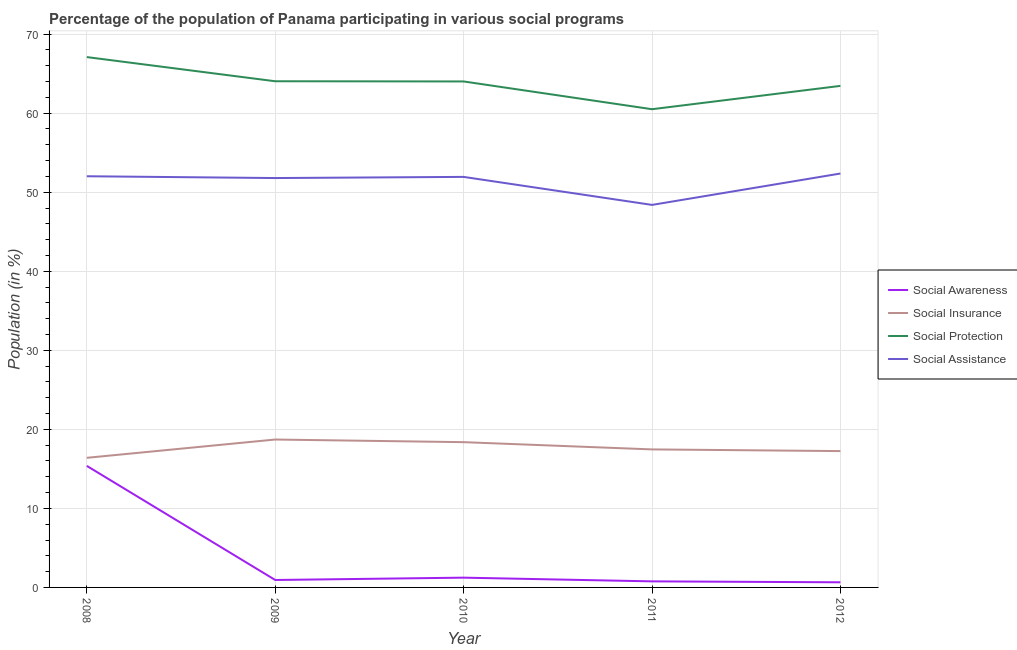How many different coloured lines are there?
Provide a succinct answer. 4. Does the line corresponding to participation of population in social assistance programs intersect with the line corresponding to participation of population in social insurance programs?
Ensure brevity in your answer.  No. What is the participation of population in social awareness programs in 2009?
Ensure brevity in your answer.  0.94. Across all years, what is the maximum participation of population in social insurance programs?
Give a very brief answer. 18.71. Across all years, what is the minimum participation of population in social assistance programs?
Offer a terse response. 48.4. In which year was the participation of population in social protection programs minimum?
Your response must be concise. 2011. What is the total participation of population in social assistance programs in the graph?
Keep it short and to the point. 256.52. What is the difference between the participation of population in social insurance programs in 2008 and that in 2009?
Provide a short and direct response. -2.31. What is the difference between the participation of population in social protection programs in 2009 and the participation of population in social insurance programs in 2010?
Ensure brevity in your answer.  45.66. What is the average participation of population in social protection programs per year?
Keep it short and to the point. 63.82. In the year 2012, what is the difference between the participation of population in social assistance programs and participation of population in social awareness programs?
Your response must be concise. 51.72. What is the ratio of the participation of population in social awareness programs in 2008 to that in 2009?
Give a very brief answer. 16.32. Is the participation of population in social assistance programs in 2008 less than that in 2012?
Make the answer very short. Yes. Is the difference between the participation of population in social awareness programs in 2009 and 2012 greater than the difference between the participation of population in social insurance programs in 2009 and 2012?
Your answer should be very brief. No. What is the difference between the highest and the second highest participation of population in social assistance programs?
Give a very brief answer. 0.35. What is the difference between the highest and the lowest participation of population in social protection programs?
Provide a short and direct response. 6.59. In how many years, is the participation of population in social protection programs greater than the average participation of population in social protection programs taken over all years?
Ensure brevity in your answer.  3. Is the sum of the participation of population in social insurance programs in 2008 and 2012 greater than the maximum participation of population in social awareness programs across all years?
Ensure brevity in your answer.  Yes. Is it the case that in every year, the sum of the participation of population in social protection programs and participation of population in social awareness programs is greater than the sum of participation of population in social insurance programs and participation of population in social assistance programs?
Your answer should be compact. Yes. Does the participation of population in social awareness programs monotonically increase over the years?
Keep it short and to the point. No. Is the participation of population in social insurance programs strictly less than the participation of population in social protection programs over the years?
Give a very brief answer. Yes. How many lines are there?
Your answer should be very brief. 4. Where does the legend appear in the graph?
Your response must be concise. Center right. What is the title of the graph?
Provide a short and direct response. Percentage of the population of Panama participating in various social programs . Does "Debt policy" appear as one of the legend labels in the graph?
Provide a short and direct response. No. What is the label or title of the X-axis?
Offer a very short reply. Year. What is the Population (in %) in Social Awareness in 2008?
Provide a short and direct response. 15.38. What is the Population (in %) of Social Insurance in 2008?
Give a very brief answer. 16.4. What is the Population (in %) in Social Protection in 2008?
Your response must be concise. 67.1. What is the Population (in %) of Social Assistance in 2008?
Make the answer very short. 52.02. What is the Population (in %) of Social Awareness in 2009?
Offer a terse response. 0.94. What is the Population (in %) in Social Insurance in 2009?
Ensure brevity in your answer.  18.71. What is the Population (in %) in Social Protection in 2009?
Offer a very short reply. 64.04. What is the Population (in %) in Social Assistance in 2009?
Provide a succinct answer. 51.79. What is the Population (in %) of Social Awareness in 2010?
Provide a succinct answer. 1.24. What is the Population (in %) of Social Insurance in 2010?
Provide a succinct answer. 18.38. What is the Population (in %) of Social Protection in 2010?
Offer a terse response. 64.02. What is the Population (in %) of Social Assistance in 2010?
Make the answer very short. 51.94. What is the Population (in %) in Social Awareness in 2011?
Your answer should be compact. 0.77. What is the Population (in %) in Social Insurance in 2011?
Keep it short and to the point. 17.46. What is the Population (in %) in Social Protection in 2011?
Offer a very short reply. 60.5. What is the Population (in %) in Social Assistance in 2011?
Offer a terse response. 48.4. What is the Population (in %) in Social Awareness in 2012?
Your answer should be compact. 0.65. What is the Population (in %) in Social Insurance in 2012?
Offer a terse response. 17.25. What is the Population (in %) in Social Protection in 2012?
Make the answer very short. 63.45. What is the Population (in %) of Social Assistance in 2012?
Give a very brief answer. 52.37. Across all years, what is the maximum Population (in %) of Social Awareness?
Make the answer very short. 15.38. Across all years, what is the maximum Population (in %) in Social Insurance?
Your answer should be compact. 18.71. Across all years, what is the maximum Population (in %) of Social Protection?
Your answer should be compact. 67.1. Across all years, what is the maximum Population (in %) in Social Assistance?
Give a very brief answer. 52.37. Across all years, what is the minimum Population (in %) of Social Awareness?
Make the answer very short. 0.65. Across all years, what is the minimum Population (in %) in Social Insurance?
Give a very brief answer. 16.4. Across all years, what is the minimum Population (in %) of Social Protection?
Your answer should be very brief. 60.5. Across all years, what is the minimum Population (in %) of Social Assistance?
Give a very brief answer. 48.4. What is the total Population (in %) of Social Awareness in the graph?
Your answer should be very brief. 18.97. What is the total Population (in %) of Social Insurance in the graph?
Keep it short and to the point. 88.2. What is the total Population (in %) in Social Protection in the graph?
Offer a terse response. 319.11. What is the total Population (in %) in Social Assistance in the graph?
Keep it short and to the point. 256.52. What is the difference between the Population (in %) in Social Awareness in 2008 and that in 2009?
Ensure brevity in your answer.  14.43. What is the difference between the Population (in %) of Social Insurance in 2008 and that in 2009?
Your answer should be very brief. -2.31. What is the difference between the Population (in %) in Social Protection in 2008 and that in 2009?
Your answer should be very brief. 3.06. What is the difference between the Population (in %) of Social Assistance in 2008 and that in 2009?
Your response must be concise. 0.23. What is the difference between the Population (in %) of Social Awareness in 2008 and that in 2010?
Provide a short and direct response. 14.14. What is the difference between the Population (in %) in Social Insurance in 2008 and that in 2010?
Provide a short and direct response. -1.98. What is the difference between the Population (in %) of Social Protection in 2008 and that in 2010?
Offer a very short reply. 3.08. What is the difference between the Population (in %) in Social Assistance in 2008 and that in 2010?
Make the answer very short. 0.08. What is the difference between the Population (in %) in Social Awareness in 2008 and that in 2011?
Give a very brief answer. 14.61. What is the difference between the Population (in %) in Social Insurance in 2008 and that in 2011?
Keep it short and to the point. -1.06. What is the difference between the Population (in %) of Social Protection in 2008 and that in 2011?
Ensure brevity in your answer.  6.59. What is the difference between the Population (in %) in Social Assistance in 2008 and that in 2011?
Offer a very short reply. 3.62. What is the difference between the Population (in %) of Social Awareness in 2008 and that in 2012?
Ensure brevity in your answer.  14.73. What is the difference between the Population (in %) in Social Insurance in 2008 and that in 2012?
Keep it short and to the point. -0.85. What is the difference between the Population (in %) in Social Protection in 2008 and that in 2012?
Keep it short and to the point. 3.64. What is the difference between the Population (in %) of Social Assistance in 2008 and that in 2012?
Offer a very short reply. -0.35. What is the difference between the Population (in %) in Social Awareness in 2009 and that in 2010?
Make the answer very short. -0.29. What is the difference between the Population (in %) in Social Insurance in 2009 and that in 2010?
Your response must be concise. 0.33. What is the difference between the Population (in %) in Social Protection in 2009 and that in 2010?
Give a very brief answer. 0.02. What is the difference between the Population (in %) in Social Assistance in 2009 and that in 2010?
Provide a short and direct response. -0.15. What is the difference between the Population (in %) in Social Awareness in 2009 and that in 2011?
Offer a very short reply. 0.17. What is the difference between the Population (in %) in Social Insurance in 2009 and that in 2011?
Provide a succinct answer. 1.25. What is the difference between the Population (in %) of Social Protection in 2009 and that in 2011?
Offer a very short reply. 3.54. What is the difference between the Population (in %) of Social Assistance in 2009 and that in 2011?
Give a very brief answer. 3.4. What is the difference between the Population (in %) of Social Awareness in 2009 and that in 2012?
Your answer should be compact. 0.29. What is the difference between the Population (in %) of Social Insurance in 2009 and that in 2012?
Your answer should be very brief. 1.46. What is the difference between the Population (in %) of Social Protection in 2009 and that in 2012?
Your answer should be compact. 0.59. What is the difference between the Population (in %) of Social Assistance in 2009 and that in 2012?
Ensure brevity in your answer.  -0.57. What is the difference between the Population (in %) of Social Awareness in 2010 and that in 2011?
Give a very brief answer. 0.47. What is the difference between the Population (in %) in Social Insurance in 2010 and that in 2011?
Make the answer very short. 0.92. What is the difference between the Population (in %) of Social Protection in 2010 and that in 2011?
Give a very brief answer. 3.51. What is the difference between the Population (in %) of Social Assistance in 2010 and that in 2011?
Ensure brevity in your answer.  3.54. What is the difference between the Population (in %) of Social Awareness in 2010 and that in 2012?
Give a very brief answer. 0.59. What is the difference between the Population (in %) of Social Insurance in 2010 and that in 2012?
Keep it short and to the point. 1.13. What is the difference between the Population (in %) in Social Protection in 2010 and that in 2012?
Your answer should be very brief. 0.56. What is the difference between the Population (in %) in Social Assistance in 2010 and that in 2012?
Keep it short and to the point. -0.43. What is the difference between the Population (in %) in Social Awareness in 2011 and that in 2012?
Provide a short and direct response. 0.12. What is the difference between the Population (in %) of Social Insurance in 2011 and that in 2012?
Keep it short and to the point. 0.21. What is the difference between the Population (in %) of Social Protection in 2011 and that in 2012?
Provide a short and direct response. -2.95. What is the difference between the Population (in %) of Social Assistance in 2011 and that in 2012?
Make the answer very short. -3.97. What is the difference between the Population (in %) of Social Awareness in 2008 and the Population (in %) of Social Insurance in 2009?
Keep it short and to the point. -3.34. What is the difference between the Population (in %) of Social Awareness in 2008 and the Population (in %) of Social Protection in 2009?
Your answer should be very brief. -48.66. What is the difference between the Population (in %) of Social Awareness in 2008 and the Population (in %) of Social Assistance in 2009?
Make the answer very short. -36.42. What is the difference between the Population (in %) in Social Insurance in 2008 and the Population (in %) in Social Protection in 2009?
Your answer should be compact. -47.64. What is the difference between the Population (in %) in Social Insurance in 2008 and the Population (in %) in Social Assistance in 2009?
Offer a very short reply. -35.39. What is the difference between the Population (in %) in Social Protection in 2008 and the Population (in %) in Social Assistance in 2009?
Make the answer very short. 15.3. What is the difference between the Population (in %) in Social Awareness in 2008 and the Population (in %) in Social Insurance in 2010?
Give a very brief answer. -3. What is the difference between the Population (in %) of Social Awareness in 2008 and the Population (in %) of Social Protection in 2010?
Your answer should be very brief. -48.64. What is the difference between the Population (in %) of Social Awareness in 2008 and the Population (in %) of Social Assistance in 2010?
Give a very brief answer. -36.56. What is the difference between the Population (in %) in Social Insurance in 2008 and the Population (in %) in Social Protection in 2010?
Your response must be concise. -47.62. What is the difference between the Population (in %) of Social Insurance in 2008 and the Population (in %) of Social Assistance in 2010?
Ensure brevity in your answer.  -35.54. What is the difference between the Population (in %) in Social Protection in 2008 and the Population (in %) in Social Assistance in 2010?
Keep it short and to the point. 15.16. What is the difference between the Population (in %) in Social Awareness in 2008 and the Population (in %) in Social Insurance in 2011?
Ensure brevity in your answer.  -2.09. What is the difference between the Population (in %) of Social Awareness in 2008 and the Population (in %) of Social Protection in 2011?
Offer a terse response. -45.13. What is the difference between the Population (in %) in Social Awareness in 2008 and the Population (in %) in Social Assistance in 2011?
Make the answer very short. -33.02. What is the difference between the Population (in %) in Social Insurance in 2008 and the Population (in %) in Social Protection in 2011?
Ensure brevity in your answer.  -44.1. What is the difference between the Population (in %) of Social Insurance in 2008 and the Population (in %) of Social Assistance in 2011?
Your answer should be compact. -32. What is the difference between the Population (in %) of Social Protection in 2008 and the Population (in %) of Social Assistance in 2011?
Keep it short and to the point. 18.7. What is the difference between the Population (in %) of Social Awareness in 2008 and the Population (in %) of Social Insurance in 2012?
Ensure brevity in your answer.  -1.87. What is the difference between the Population (in %) of Social Awareness in 2008 and the Population (in %) of Social Protection in 2012?
Make the answer very short. -48.08. What is the difference between the Population (in %) in Social Awareness in 2008 and the Population (in %) in Social Assistance in 2012?
Your answer should be very brief. -36.99. What is the difference between the Population (in %) in Social Insurance in 2008 and the Population (in %) in Social Protection in 2012?
Offer a terse response. -47.05. What is the difference between the Population (in %) in Social Insurance in 2008 and the Population (in %) in Social Assistance in 2012?
Provide a succinct answer. -35.97. What is the difference between the Population (in %) in Social Protection in 2008 and the Population (in %) in Social Assistance in 2012?
Provide a succinct answer. 14.73. What is the difference between the Population (in %) of Social Awareness in 2009 and the Population (in %) of Social Insurance in 2010?
Your answer should be compact. -17.44. What is the difference between the Population (in %) in Social Awareness in 2009 and the Population (in %) in Social Protection in 2010?
Offer a terse response. -63.07. What is the difference between the Population (in %) in Social Awareness in 2009 and the Population (in %) in Social Assistance in 2010?
Provide a succinct answer. -51. What is the difference between the Population (in %) in Social Insurance in 2009 and the Population (in %) in Social Protection in 2010?
Your response must be concise. -45.3. What is the difference between the Population (in %) of Social Insurance in 2009 and the Population (in %) of Social Assistance in 2010?
Make the answer very short. -33.23. What is the difference between the Population (in %) in Social Protection in 2009 and the Population (in %) in Social Assistance in 2010?
Offer a terse response. 12.1. What is the difference between the Population (in %) of Social Awareness in 2009 and the Population (in %) of Social Insurance in 2011?
Offer a very short reply. -16.52. What is the difference between the Population (in %) of Social Awareness in 2009 and the Population (in %) of Social Protection in 2011?
Provide a succinct answer. -59.56. What is the difference between the Population (in %) of Social Awareness in 2009 and the Population (in %) of Social Assistance in 2011?
Your response must be concise. -47.45. What is the difference between the Population (in %) of Social Insurance in 2009 and the Population (in %) of Social Protection in 2011?
Offer a very short reply. -41.79. What is the difference between the Population (in %) in Social Insurance in 2009 and the Population (in %) in Social Assistance in 2011?
Provide a succinct answer. -29.68. What is the difference between the Population (in %) in Social Protection in 2009 and the Population (in %) in Social Assistance in 2011?
Ensure brevity in your answer.  15.64. What is the difference between the Population (in %) in Social Awareness in 2009 and the Population (in %) in Social Insurance in 2012?
Ensure brevity in your answer.  -16.31. What is the difference between the Population (in %) in Social Awareness in 2009 and the Population (in %) in Social Protection in 2012?
Your response must be concise. -62.51. What is the difference between the Population (in %) in Social Awareness in 2009 and the Population (in %) in Social Assistance in 2012?
Provide a short and direct response. -51.42. What is the difference between the Population (in %) in Social Insurance in 2009 and the Population (in %) in Social Protection in 2012?
Your response must be concise. -44.74. What is the difference between the Population (in %) of Social Insurance in 2009 and the Population (in %) of Social Assistance in 2012?
Your answer should be very brief. -33.65. What is the difference between the Population (in %) in Social Protection in 2009 and the Population (in %) in Social Assistance in 2012?
Provide a short and direct response. 11.67. What is the difference between the Population (in %) in Social Awareness in 2010 and the Population (in %) in Social Insurance in 2011?
Give a very brief answer. -16.23. What is the difference between the Population (in %) of Social Awareness in 2010 and the Population (in %) of Social Protection in 2011?
Offer a terse response. -59.27. What is the difference between the Population (in %) in Social Awareness in 2010 and the Population (in %) in Social Assistance in 2011?
Make the answer very short. -47.16. What is the difference between the Population (in %) of Social Insurance in 2010 and the Population (in %) of Social Protection in 2011?
Provide a succinct answer. -42.12. What is the difference between the Population (in %) of Social Insurance in 2010 and the Population (in %) of Social Assistance in 2011?
Ensure brevity in your answer.  -30.02. What is the difference between the Population (in %) in Social Protection in 2010 and the Population (in %) in Social Assistance in 2011?
Your answer should be compact. 15.62. What is the difference between the Population (in %) in Social Awareness in 2010 and the Population (in %) in Social Insurance in 2012?
Offer a very short reply. -16.01. What is the difference between the Population (in %) in Social Awareness in 2010 and the Population (in %) in Social Protection in 2012?
Ensure brevity in your answer.  -62.22. What is the difference between the Population (in %) of Social Awareness in 2010 and the Population (in %) of Social Assistance in 2012?
Your answer should be very brief. -51.13. What is the difference between the Population (in %) in Social Insurance in 2010 and the Population (in %) in Social Protection in 2012?
Give a very brief answer. -45.07. What is the difference between the Population (in %) in Social Insurance in 2010 and the Population (in %) in Social Assistance in 2012?
Provide a short and direct response. -33.99. What is the difference between the Population (in %) of Social Protection in 2010 and the Population (in %) of Social Assistance in 2012?
Ensure brevity in your answer.  11.65. What is the difference between the Population (in %) of Social Awareness in 2011 and the Population (in %) of Social Insurance in 2012?
Ensure brevity in your answer.  -16.48. What is the difference between the Population (in %) in Social Awareness in 2011 and the Population (in %) in Social Protection in 2012?
Provide a short and direct response. -62.69. What is the difference between the Population (in %) of Social Awareness in 2011 and the Population (in %) of Social Assistance in 2012?
Your response must be concise. -51.6. What is the difference between the Population (in %) of Social Insurance in 2011 and the Population (in %) of Social Protection in 2012?
Your answer should be compact. -45.99. What is the difference between the Population (in %) of Social Insurance in 2011 and the Population (in %) of Social Assistance in 2012?
Offer a very short reply. -34.9. What is the difference between the Population (in %) of Social Protection in 2011 and the Population (in %) of Social Assistance in 2012?
Make the answer very short. 8.14. What is the average Population (in %) of Social Awareness per year?
Provide a succinct answer. 3.79. What is the average Population (in %) in Social Insurance per year?
Your answer should be compact. 17.64. What is the average Population (in %) in Social Protection per year?
Your answer should be very brief. 63.82. What is the average Population (in %) of Social Assistance per year?
Provide a short and direct response. 51.3. In the year 2008, what is the difference between the Population (in %) in Social Awareness and Population (in %) in Social Insurance?
Ensure brevity in your answer.  -1.02. In the year 2008, what is the difference between the Population (in %) of Social Awareness and Population (in %) of Social Protection?
Offer a very short reply. -51.72. In the year 2008, what is the difference between the Population (in %) in Social Awareness and Population (in %) in Social Assistance?
Provide a succinct answer. -36.65. In the year 2008, what is the difference between the Population (in %) in Social Insurance and Population (in %) in Social Protection?
Keep it short and to the point. -50.7. In the year 2008, what is the difference between the Population (in %) in Social Insurance and Population (in %) in Social Assistance?
Offer a very short reply. -35.62. In the year 2008, what is the difference between the Population (in %) of Social Protection and Population (in %) of Social Assistance?
Your response must be concise. 15.08. In the year 2009, what is the difference between the Population (in %) of Social Awareness and Population (in %) of Social Insurance?
Offer a very short reply. -17.77. In the year 2009, what is the difference between the Population (in %) in Social Awareness and Population (in %) in Social Protection?
Your answer should be compact. -63.1. In the year 2009, what is the difference between the Population (in %) in Social Awareness and Population (in %) in Social Assistance?
Your answer should be compact. -50.85. In the year 2009, what is the difference between the Population (in %) of Social Insurance and Population (in %) of Social Protection?
Give a very brief answer. -45.33. In the year 2009, what is the difference between the Population (in %) in Social Insurance and Population (in %) in Social Assistance?
Your answer should be compact. -33.08. In the year 2009, what is the difference between the Population (in %) of Social Protection and Population (in %) of Social Assistance?
Ensure brevity in your answer.  12.25. In the year 2010, what is the difference between the Population (in %) of Social Awareness and Population (in %) of Social Insurance?
Ensure brevity in your answer.  -17.14. In the year 2010, what is the difference between the Population (in %) of Social Awareness and Population (in %) of Social Protection?
Provide a short and direct response. -62.78. In the year 2010, what is the difference between the Population (in %) in Social Awareness and Population (in %) in Social Assistance?
Your response must be concise. -50.7. In the year 2010, what is the difference between the Population (in %) of Social Insurance and Population (in %) of Social Protection?
Make the answer very short. -45.64. In the year 2010, what is the difference between the Population (in %) of Social Insurance and Population (in %) of Social Assistance?
Provide a succinct answer. -33.56. In the year 2010, what is the difference between the Population (in %) of Social Protection and Population (in %) of Social Assistance?
Your answer should be very brief. 12.08. In the year 2011, what is the difference between the Population (in %) of Social Awareness and Population (in %) of Social Insurance?
Ensure brevity in your answer.  -16.7. In the year 2011, what is the difference between the Population (in %) in Social Awareness and Population (in %) in Social Protection?
Provide a short and direct response. -59.74. In the year 2011, what is the difference between the Population (in %) in Social Awareness and Population (in %) in Social Assistance?
Give a very brief answer. -47.63. In the year 2011, what is the difference between the Population (in %) of Social Insurance and Population (in %) of Social Protection?
Make the answer very short. -43.04. In the year 2011, what is the difference between the Population (in %) in Social Insurance and Population (in %) in Social Assistance?
Your answer should be very brief. -30.93. In the year 2011, what is the difference between the Population (in %) in Social Protection and Population (in %) in Social Assistance?
Keep it short and to the point. 12.11. In the year 2012, what is the difference between the Population (in %) of Social Awareness and Population (in %) of Social Insurance?
Offer a terse response. -16.6. In the year 2012, what is the difference between the Population (in %) of Social Awareness and Population (in %) of Social Protection?
Keep it short and to the point. -62.8. In the year 2012, what is the difference between the Population (in %) of Social Awareness and Population (in %) of Social Assistance?
Offer a very short reply. -51.72. In the year 2012, what is the difference between the Population (in %) in Social Insurance and Population (in %) in Social Protection?
Offer a terse response. -46.2. In the year 2012, what is the difference between the Population (in %) of Social Insurance and Population (in %) of Social Assistance?
Offer a very short reply. -35.12. In the year 2012, what is the difference between the Population (in %) in Social Protection and Population (in %) in Social Assistance?
Keep it short and to the point. 11.09. What is the ratio of the Population (in %) of Social Awareness in 2008 to that in 2009?
Your answer should be compact. 16.32. What is the ratio of the Population (in %) in Social Insurance in 2008 to that in 2009?
Provide a succinct answer. 0.88. What is the ratio of the Population (in %) of Social Protection in 2008 to that in 2009?
Your answer should be very brief. 1.05. What is the ratio of the Population (in %) in Social Awareness in 2008 to that in 2010?
Your answer should be compact. 12.44. What is the ratio of the Population (in %) in Social Insurance in 2008 to that in 2010?
Your response must be concise. 0.89. What is the ratio of the Population (in %) in Social Protection in 2008 to that in 2010?
Your answer should be very brief. 1.05. What is the ratio of the Population (in %) of Social Awareness in 2008 to that in 2011?
Provide a succinct answer. 20.04. What is the ratio of the Population (in %) of Social Insurance in 2008 to that in 2011?
Your response must be concise. 0.94. What is the ratio of the Population (in %) of Social Protection in 2008 to that in 2011?
Keep it short and to the point. 1.11. What is the ratio of the Population (in %) in Social Assistance in 2008 to that in 2011?
Ensure brevity in your answer.  1.07. What is the ratio of the Population (in %) in Social Awareness in 2008 to that in 2012?
Keep it short and to the point. 23.67. What is the ratio of the Population (in %) in Social Insurance in 2008 to that in 2012?
Ensure brevity in your answer.  0.95. What is the ratio of the Population (in %) in Social Protection in 2008 to that in 2012?
Keep it short and to the point. 1.06. What is the ratio of the Population (in %) of Social Assistance in 2008 to that in 2012?
Your answer should be compact. 0.99. What is the ratio of the Population (in %) of Social Awareness in 2009 to that in 2010?
Ensure brevity in your answer.  0.76. What is the ratio of the Population (in %) of Social Insurance in 2009 to that in 2010?
Your answer should be compact. 1.02. What is the ratio of the Population (in %) in Social Awareness in 2009 to that in 2011?
Make the answer very short. 1.23. What is the ratio of the Population (in %) of Social Insurance in 2009 to that in 2011?
Your answer should be very brief. 1.07. What is the ratio of the Population (in %) in Social Protection in 2009 to that in 2011?
Give a very brief answer. 1.06. What is the ratio of the Population (in %) in Social Assistance in 2009 to that in 2011?
Provide a short and direct response. 1.07. What is the ratio of the Population (in %) of Social Awareness in 2009 to that in 2012?
Make the answer very short. 1.45. What is the ratio of the Population (in %) in Social Insurance in 2009 to that in 2012?
Keep it short and to the point. 1.08. What is the ratio of the Population (in %) in Social Protection in 2009 to that in 2012?
Your response must be concise. 1.01. What is the ratio of the Population (in %) of Social Assistance in 2009 to that in 2012?
Offer a terse response. 0.99. What is the ratio of the Population (in %) in Social Awareness in 2010 to that in 2011?
Your answer should be very brief. 1.61. What is the ratio of the Population (in %) of Social Insurance in 2010 to that in 2011?
Provide a succinct answer. 1.05. What is the ratio of the Population (in %) in Social Protection in 2010 to that in 2011?
Your answer should be very brief. 1.06. What is the ratio of the Population (in %) of Social Assistance in 2010 to that in 2011?
Your answer should be very brief. 1.07. What is the ratio of the Population (in %) in Social Awareness in 2010 to that in 2012?
Your answer should be compact. 1.9. What is the ratio of the Population (in %) in Social Insurance in 2010 to that in 2012?
Offer a very short reply. 1.07. What is the ratio of the Population (in %) of Social Protection in 2010 to that in 2012?
Your response must be concise. 1.01. What is the ratio of the Population (in %) of Social Assistance in 2010 to that in 2012?
Keep it short and to the point. 0.99. What is the ratio of the Population (in %) of Social Awareness in 2011 to that in 2012?
Provide a succinct answer. 1.18. What is the ratio of the Population (in %) of Social Insurance in 2011 to that in 2012?
Offer a very short reply. 1.01. What is the ratio of the Population (in %) in Social Protection in 2011 to that in 2012?
Your answer should be very brief. 0.95. What is the ratio of the Population (in %) in Social Assistance in 2011 to that in 2012?
Offer a terse response. 0.92. What is the difference between the highest and the second highest Population (in %) of Social Awareness?
Provide a succinct answer. 14.14. What is the difference between the highest and the second highest Population (in %) in Social Insurance?
Provide a succinct answer. 0.33. What is the difference between the highest and the second highest Population (in %) of Social Protection?
Offer a very short reply. 3.06. What is the difference between the highest and the second highest Population (in %) in Social Assistance?
Offer a terse response. 0.35. What is the difference between the highest and the lowest Population (in %) of Social Awareness?
Your answer should be compact. 14.73. What is the difference between the highest and the lowest Population (in %) in Social Insurance?
Your response must be concise. 2.31. What is the difference between the highest and the lowest Population (in %) of Social Protection?
Provide a short and direct response. 6.59. What is the difference between the highest and the lowest Population (in %) in Social Assistance?
Your response must be concise. 3.97. 